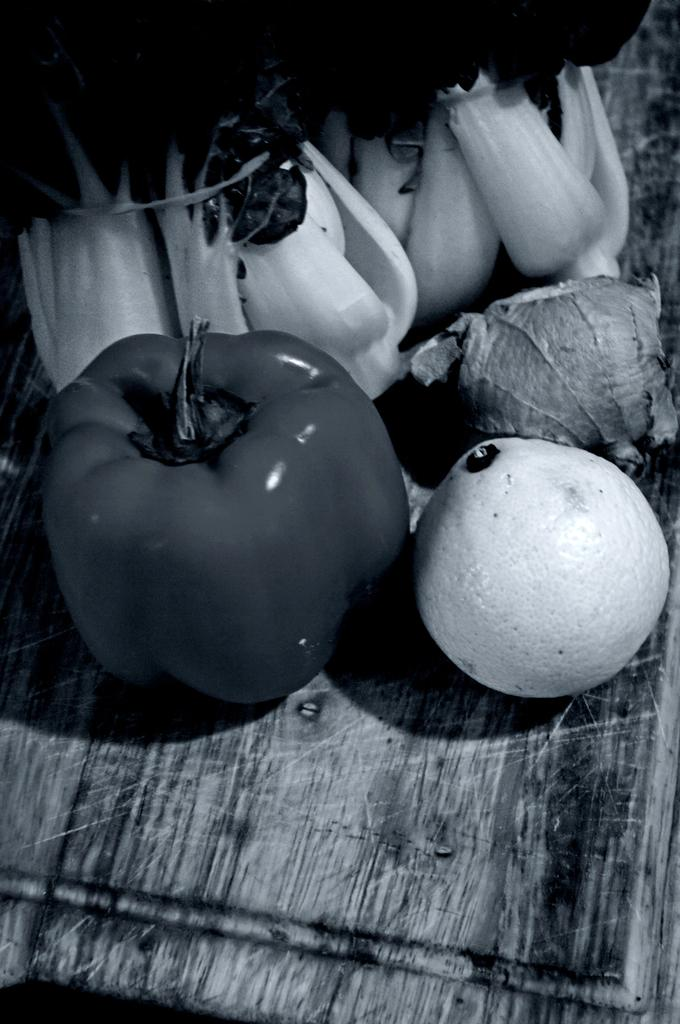What is the color scheme of the image? The image is black and white. What type of vegetable can be seen in the image? There is a capsicum in the image. Are there any other vegetables visible in the image? Yes, there are other vegetables in the image. What grade of light bulb is used in the image? There is no light bulb present in the image, as it is a black and white image of vegetables. 